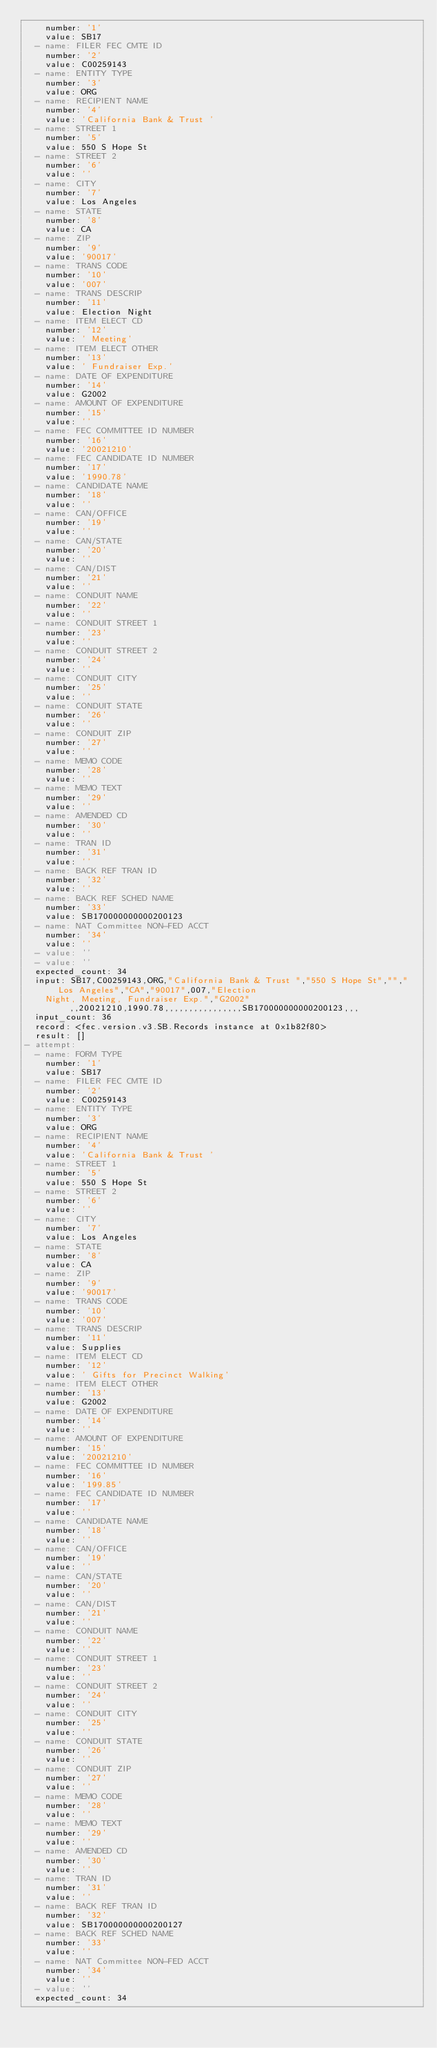<code> <loc_0><loc_0><loc_500><loc_500><_YAML_>    number: '1'
    value: SB17
  - name: FILER FEC CMTE ID
    number: '2'
    value: C00259143
  - name: ENTITY TYPE
    number: '3'
    value: ORG
  - name: RECIPIENT NAME
    number: '4'
    value: 'California Bank & Trust '
  - name: STREET 1
    number: '5'
    value: 550 S Hope St
  - name: STREET 2
    number: '6'
    value: ''
  - name: CITY
    number: '7'
    value: Los Angeles
  - name: STATE
    number: '8'
    value: CA
  - name: ZIP
    number: '9'
    value: '90017'
  - name: TRANS CODE
    number: '10'
    value: '007'
  - name: TRANS DESCRIP
    number: '11'
    value: Election Night
  - name: ITEM ELECT CD
    number: '12'
    value: ' Meeting'
  - name: ITEM ELECT OTHER
    number: '13'
    value: ' Fundraiser Exp.'
  - name: DATE OF EXPENDITURE
    number: '14'
    value: G2002
  - name: AMOUNT OF EXPENDITURE
    number: '15'
    value: ''
  - name: FEC COMMITTEE ID NUMBER
    number: '16'
    value: '20021210'
  - name: FEC CANDIDATE ID NUMBER
    number: '17'
    value: '1990.78'
  - name: CANDIDATE NAME
    number: '18'
    value: ''
  - name: CAN/OFFICE
    number: '19'
    value: ''
  - name: CAN/STATE
    number: '20'
    value: ''
  - name: CAN/DIST
    number: '21'
    value: ''
  - name: CONDUIT NAME
    number: '22'
    value: ''
  - name: CONDUIT STREET 1
    number: '23'
    value: ''
  - name: CONDUIT STREET 2
    number: '24'
    value: ''
  - name: CONDUIT CITY
    number: '25'
    value: ''
  - name: CONDUIT STATE
    number: '26'
    value: ''
  - name: CONDUIT ZIP
    number: '27'
    value: ''
  - name: MEMO CODE
    number: '28'
    value: ''
  - name: MEMO TEXT
    number: '29'
    value: ''
  - name: AMENDED CD
    number: '30'
    value: ''
  - name: TRAN ID
    number: '31'
    value: ''
  - name: BACK REF TRAN ID
    number: '32'
    value: ''
  - name: BACK REF SCHED NAME
    number: '33'
    value: SB170000000000200123
  - name: NAT Committee NON-FED ACCT
    number: '34'
    value: ''
  - value: ''
  - value: ''
  expected_count: 34
  input: SB17,C00259143,ORG,"California Bank & Trust ","550 S Hope St","","Los Angeles","CA","90017",007,"Election
    Night, Meeting, Fundraiser Exp.","G2002",,20021210,1990.78,,,,,,,,,,,,,,,,SB170000000000200123,,,
  input_count: 36
  record: <fec.version.v3.SB.Records instance at 0x1b82f80>
  result: []
- attempt:
  - name: FORM TYPE
    number: '1'
    value: SB17
  - name: FILER FEC CMTE ID
    number: '2'
    value: C00259143
  - name: ENTITY TYPE
    number: '3'
    value: ORG
  - name: RECIPIENT NAME
    number: '4'
    value: 'California Bank & Trust '
  - name: STREET 1
    number: '5'
    value: 550 S Hope St
  - name: STREET 2
    number: '6'
    value: ''
  - name: CITY
    number: '7'
    value: Los Angeles
  - name: STATE
    number: '8'
    value: CA
  - name: ZIP
    number: '9'
    value: '90017'
  - name: TRANS CODE
    number: '10'
    value: '007'
  - name: TRANS DESCRIP
    number: '11'
    value: Supplies
  - name: ITEM ELECT CD
    number: '12'
    value: ' Gifts for Precinct Walking'
  - name: ITEM ELECT OTHER
    number: '13'
    value: G2002
  - name: DATE OF EXPENDITURE
    number: '14'
    value: ''
  - name: AMOUNT OF EXPENDITURE
    number: '15'
    value: '20021210'
  - name: FEC COMMITTEE ID NUMBER
    number: '16'
    value: '199.85'
  - name: FEC CANDIDATE ID NUMBER
    number: '17'
    value: ''
  - name: CANDIDATE NAME
    number: '18'
    value: ''
  - name: CAN/OFFICE
    number: '19'
    value: ''
  - name: CAN/STATE
    number: '20'
    value: ''
  - name: CAN/DIST
    number: '21'
    value: ''
  - name: CONDUIT NAME
    number: '22'
    value: ''
  - name: CONDUIT STREET 1
    number: '23'
    value: ''
  - name: CONDUIT STREET 2
    number: '24'
    value: ''
  - name: CONDUIT CITY
    number: '25'
    value: ''
  - name: CONDUIT STATE
    number: '26'
    value: ''
  - name: CONDUIT ZIP
    number: '27'
    value: ''
  - name: MEMO CODE
    number: '28'
    value: ''
  - name: MEMO TEXT
    number: '29'
    value: ''
  - name: AMENDED CD
    number: '30'
    value: ''
  - name: TRAN ID
    number: '31'
    value: ''
  - name: BACK REF TRAN ID
    number: '32'
    value: SB170000000000200127
  - name: BACK REF SCHED NAME
    number: '33'
    value: ''
  - name: NAT Committee NON-FED ACCT
    number: '34'
    value: ''
  - value: ''
  expected_count: 34</code> 